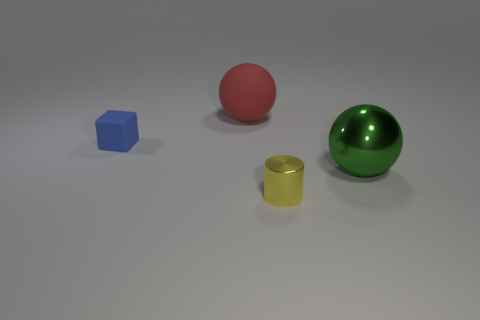Add 4 big yellow shiny cubes. How many objects exist? 8 Subtract all blocks. How many objects are left? 3 Subtract all matte cylinders. Subtract all blue blocks. How many objects are left? 3 Add 1 big red matte balls. How many big red matte balls are left? 2 Add 3 small yellow rubber cylinders. How many small yellow rubber cylinders exist? 3 Subtract 0 cyan cylinders. How many objects are left? 4 